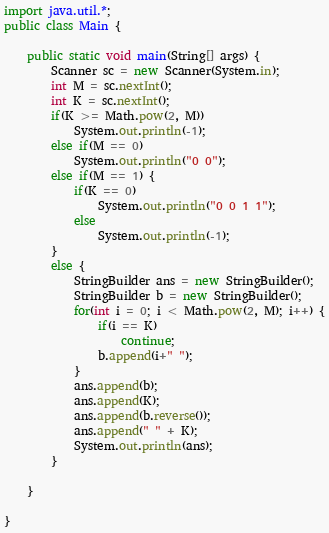<code> <loc_0><loc_0><loc_500><loc_500><_Java_>import java.util.*;
public class Main {

	public static void main(String[] args) {
		Scanner sc = new Scanner(System.in);
		int M = sc.nextInt();
		int K = sc.nextInt();
		if(K >= Math.pow(2, M))
			System.out.println(-1);
		else if(M == 0)
			System.out.println("0 0");
		else if(M == 1) {
			if(K == 0)
				System.out.println("0 0 1 1");
			else
				System.out.println(-1);
		}
		else {
			StringBuilder ans = new StringBuilder();
			StringBuilder b = new StringBuilder();
			for(int i = 0; i < Math.pow(2, M); i++) {
				if(i == K)
					continue;
				b.append(i+" ");
			}
			ans.append(b);
			ans.append(K);
			ans.append(b.reverse());
			ans.append(" " + K);
			System.out.println(ans);
		}

	}

}
</code> 